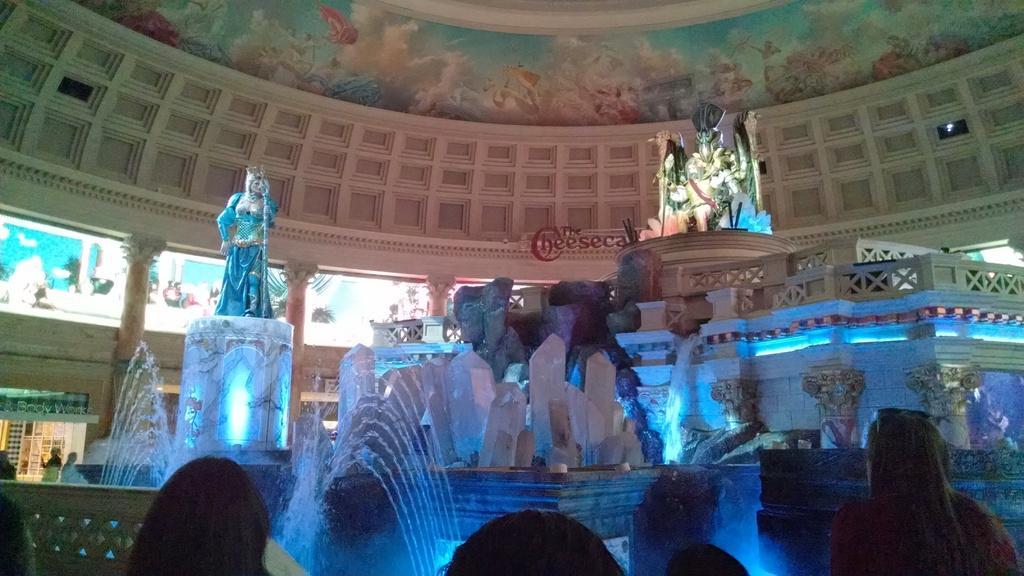In one or two sentences, can you explain what this image depicts? In this image there are few sculptures on the pillars. Left side there is water fountain. Bottom of the image there are few persons. Background there is a wall. Top of the image there is roof having few pictures are painted on it. 